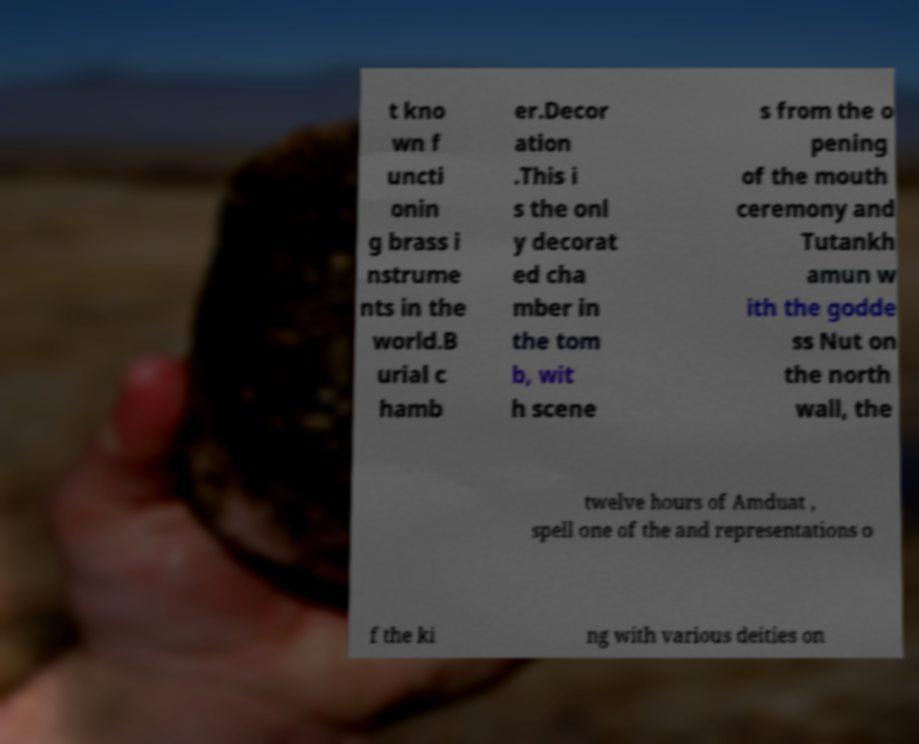I need the written content from this picture converted into text. Can you do that? t kno wn f uncti onin g brass i nstrume nts in the world.B urial c hamb er.Decor ation .This i s the onl y decorat ed cha mber in the tom b, wit h scene s from the o pening of the mouth ceremony and Tutankh amun w ith the godde ss Nut on the north wall, the twelve hours of Amduat , spell one of the and representations o f the ki ng with various deities on 